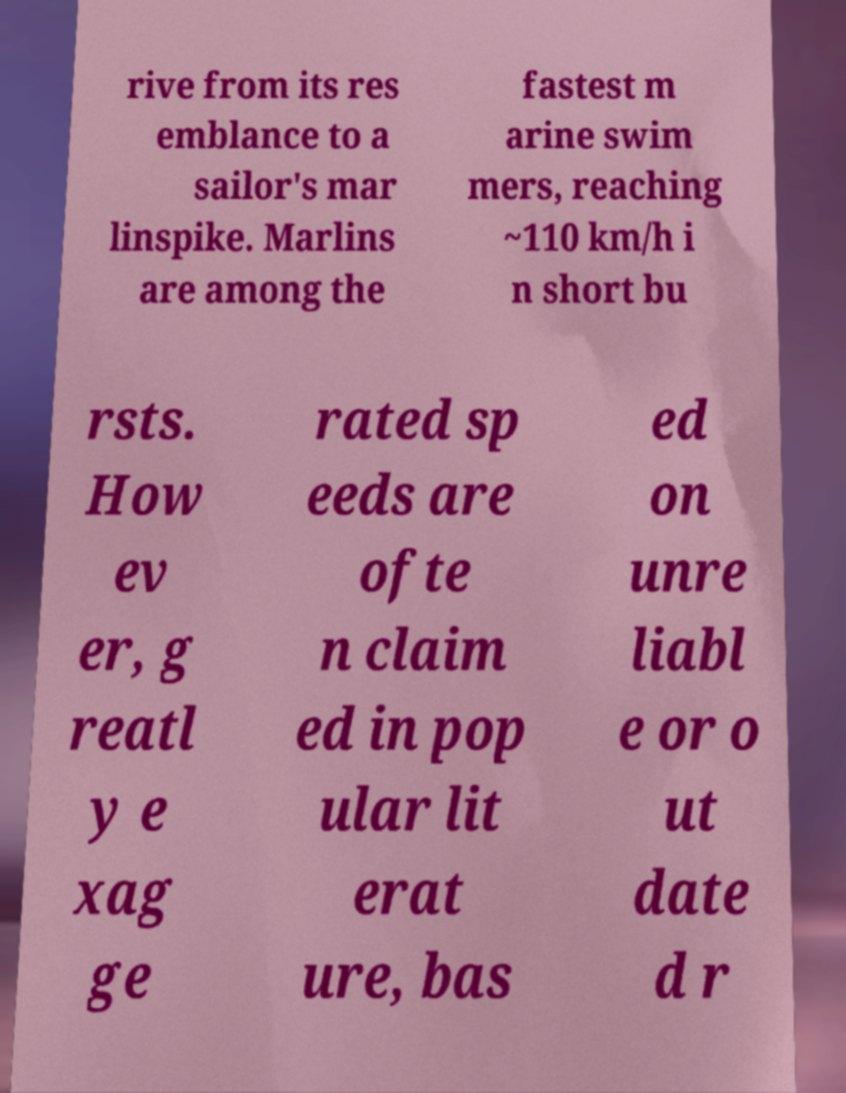Please identify and transcribe the text found in this image. rive from its res emblance to a sailor's mar linspike. Marlins are among the fastest m arine swim mers, reaching ~110 km/h i n short bu rsts. How ev er, g reatl y e xag ge rated sp eeds are ofte n claim ed in pop ular lit erat ure, bas ed on unre liabl e or o ut date d r 